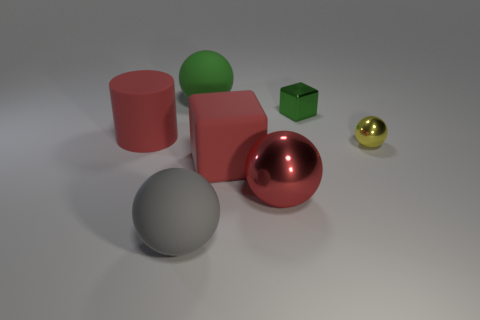How many objects are either big red cubes or large matte cylinders?
Give a very brief answer. 2. Is the material of the big red thing on the left side of the red matte cube the same as the large block?
Offer a terse response. Yes. What number of objects are big green things that are behind the gray matte sphere or large matte spheres?
Provide a short and direct response. 2. The cylinder that is made of the same material as the large gray thing is what color?
Keep it short and to the point. Red. Are there any rubber cylinders of the same size as the green matte object?
Your response must be concise. Yes. Do the large ball behind the big red ball and the tiny block have the same color?
Provide a succinct answer. Yes. There is a big matte object that is in front of the small ball and on the left side of the large green matte ball; what is its color?
Your answer should be very brief. Gray. The gray thing that is the same size as the red rubber block is what shape?
Ensure brevity in your answer.  Sphere. Are there any small green objects that have the same shape as the tiny yellow metallic thing?
Offer a very short reply. No. There is a matte ball that is behind the matte cylinder; does it have the same size as the large shiny ball?
Give a very brief answer. Yes. 